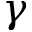Convert formula to latex. <formula><loc_0><loc_0><loc_500><loc_500>\gamma</formula> 